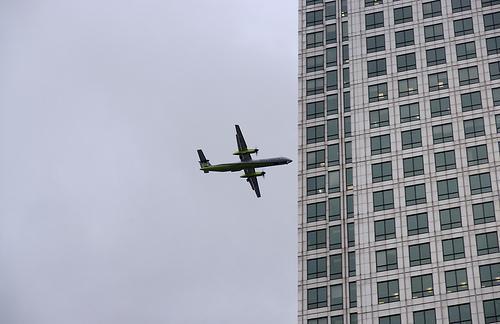How many planes are there?
Give a very brief answer. 1. 